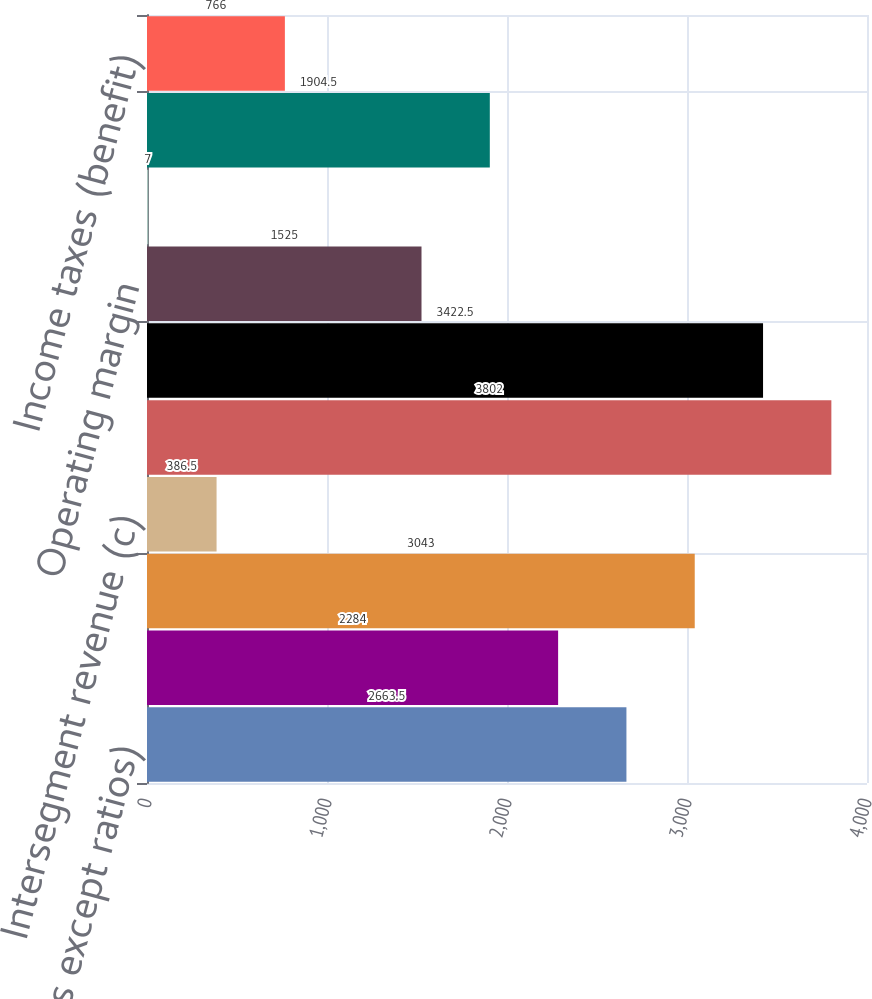<chart> <loc_0><loc_0><loc_500><loc_500><bar_chart><fcel>(in millions except ratios)<fcel>Operating net interest income<fcel>Operating noninterest revenue<fcel>Intersegment revenue (c)<fcel>Total operating revenue<fcel>Total operating expense<fcel>Operating margin<fcel>Credit costs<fcel>Operating earnings (loss)<fcel>Income taxes (benefit)<nl><fcel>2663.5<fcel>2284<fcel>3043<fcel>386.5<fcel>3802<fcel>3422.5<fcel>1525<fcel>7<fcel>1904.5<fcel>766<nl></chart> 